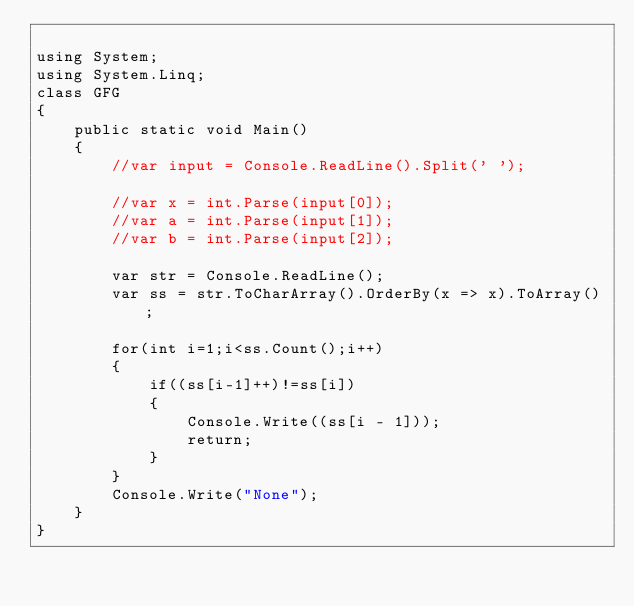<code> <loc_0><loc_0><loc_500><loc_500><_C#_>
using System;
using System.Linq;
class GFG
{
    public static void Main()
    {
        //var input = Console.ReadLine().Split(' ');

        //var x = int.Parse(input[0]);
        //var a = int.Parse(input[1]);
        //var b = int.Parse(input[2]);

        var str = Console.ReadLine();
        var ss = str.ToCharArray().OrderBy(x => x).ToArray();

        for(int i=1;i<ss.Count();i++)
        {
            if((ss[i-1]++)!=ss[i])
            {
                Console.Write((ss[i - 1]));
                return;
            }
        }
        Console.Write("None");
    }
}


</code> 